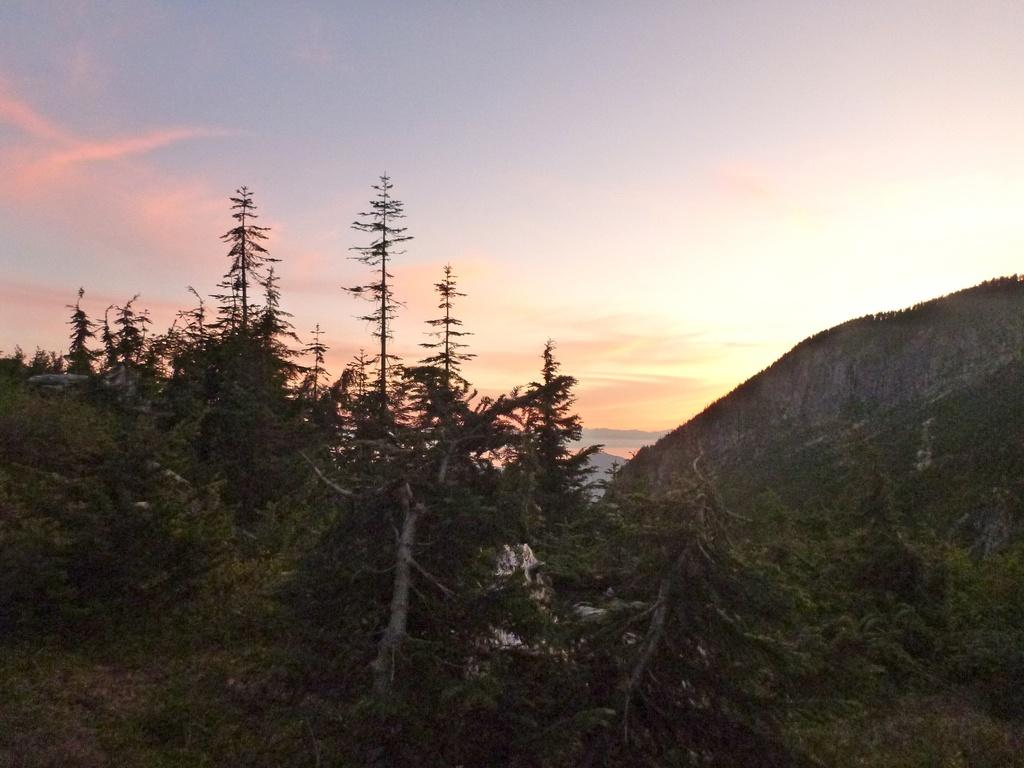What type of natural elements can be seen in the image? There are trees and a mountain in the image. What is visible in the background of the image? The sky is visible in the image. How would you describe the colors of the sky in the image? The sky has white, blue, and orange colors in the image. What type of locket is hanging from the tree in the image? There is no locket present in the image; it features trees, a mountain, and the sky. What month is depicted in the image? The image does not depict a specific month; it only shows natural elements and the sky. 